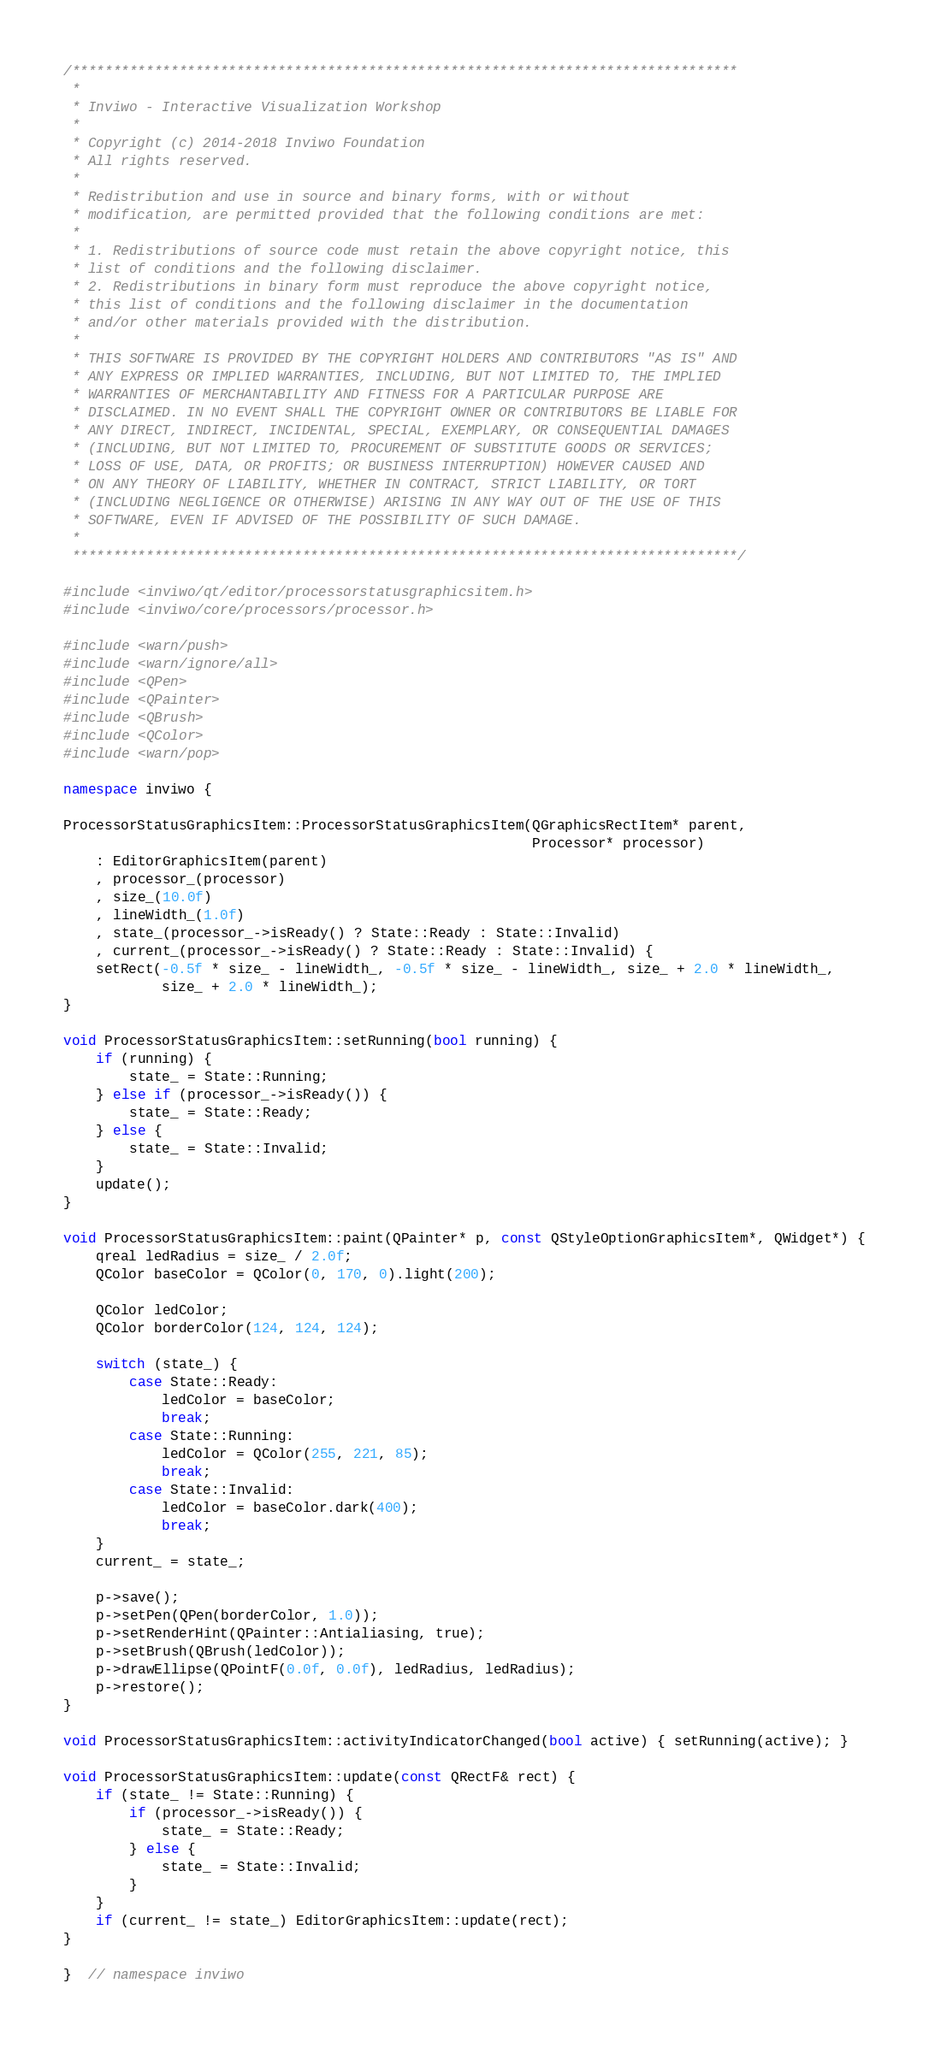<code> <loc_0><loc_0><loc_500><loc_500><_C++_>/*********************************************************************************
 *
 * Inviwo - Interactive Visualization Workshop
 *
 * Copyright (c) 2014-2018 Inviwo Foundation
 * All rights reserved.
 *
 * Redistribution and use in source and binary forms, with or without
 * modification, are permitted provided that the following conditions are met:
 *
 * 1. Redistributions of source code must retain the above copyright notice, this
 * list of conditions and the following disclaimer.
 * 2. Redistributions in binary form must reproduce the above copyright notice,
 * this list of conditions and the following disclaimer in the documentation
 * and/or other materials provided with the distribution.
 *
 * THIS SOFTWARE IS PROVIDED BY THE COPYRIGHT HOLDERS AND CONTRIBUTORS "AS IS" AND
 * ANY EXPRESS OR IMPLIED WARRANTIES, INCLUDING, BUT NOT LIMITED TO, THE IMPLIED
 * WARRANTIES OF MERCHANTABILITY AND FITNESS FOR A PARTICULAR PURPOSE ARE
 * DISCLAIMED. IN NO EVENT SHALL THE COPYRIGHT OWNER OR CONTRIBUTORS BE LIABLE FOR
 * ANY DIRECT, INDIRECT, INCIDENTAL, SPECIAL, EXEMPLARY, OR CONSEQUENTIAL DAMAGES
 * (INCLUDING, BUT NOT LIMITED TO, PROCUREMENT OF SUBSTITUTE GOODS OR SERVICES;
 * LOSS OF USE, DATA, OR PROFITS; OR BUSINESS INTERRUPTION) HOWEVER CAUSED AND
 * ON ANY THEORY OF LIABILITY, WHETHER IN CONTRACT, STRICT LIABILITY, OR TORT
 * (INCLUDING NEGLIGENCE OR OTHERWISE) ARISING IN ANY WAY OUT OF THE USE OF THIS
 * SOFTWARE, EVEN IF ADVISED OF THE POSSIBILITY OF SUCH DAMAGE.
 *
 *********************************************************************************/

#include <inviwo/qt/editor/processorstatusgraphicsitem.h>
#include <inviwo/core/processors/processor.h>

#include <warn/push>
#include <warn/ignore/all>
#include <QPen>
#include <QPainter>
#include <QBrush>
#include <QColor>
#include <warn/pop>

namespace inviwo {

ProcessorStatusGraphicsItem::ProcessorStatusGraphicsItem(QGraphicsRectItem* parent,
                                                         Processor* processor)
    : EditorGraphicsItem(parent)
    , processor_(processor)
    , size_(10.0f)
    , lineWidth_(1.0f)
    , state_(processor_->isReady() ? State::Ready : State::Invalid)
    , current_(processor_->isReady() ? State::Ready : State::Invalid) {
    setRect(-0.5f * size_ - lineWidth_, -0.5f * size_ - lineWidth_, size_ + 2.0 * lineWidth_,
            size_ + 2.0 * lineWidth_);
}

void ProcessorStatusGraphicsItem::setRunning(bool running) {
    if (running) {
        state_ = State::Running;
    } else if (processor_->isReady()) {
        state_ = State::Ready;
    } else {
        state_ = State::Invalid;
    }
    update();
}

void ProcessorStatusGraphicsItem::paint(QPainter* p, const QStyleOptionGraphicsItem*, QWidget*) {
    qreal ledRadius = size_ / 2.0f;
    QColor baseColor = QColor(0, 170, 0).light(200);

    QColor ledColor;
    QColor borderColor(124, 124, 124);

    switch (state_) {
        case State::Ready:
            ledColor = baseColor;
            break;
        case State::Running:
            ledColor = QColor(255, 221, 85);
            break;
        case State::Invalid:
            ledColor = baseColor.dark(400);
            break;
    }
    current_ = state_;

    p->save();
    p->setPen(QPen(borderColor, 1.0));
    p->setRenderHint(QPainter::Antialiasing, true);
    p->setBrush(QBrush(ledColor));
    p->drawEllipse(QPointF(0.0f, 0.0f), ledRadius, ledRadius);
    p->restore();
}

void ProcessorStatusGraphicsItem::activityIndicatorChanged(bool active) { setRunning(active); }

void ProcessorStatusGraphicsItem::update(const QRectF& rect) {
    if (state_ != State::Running) {
        if (processor_->isReady()) {
            state_ = State::Ready;
        } else {
            state_ = State::Invalid;
        }
    }
    if (current_ != state_) EditorGraphicsItem::update(rect);
}

}  // namespace inviwo
</code> 